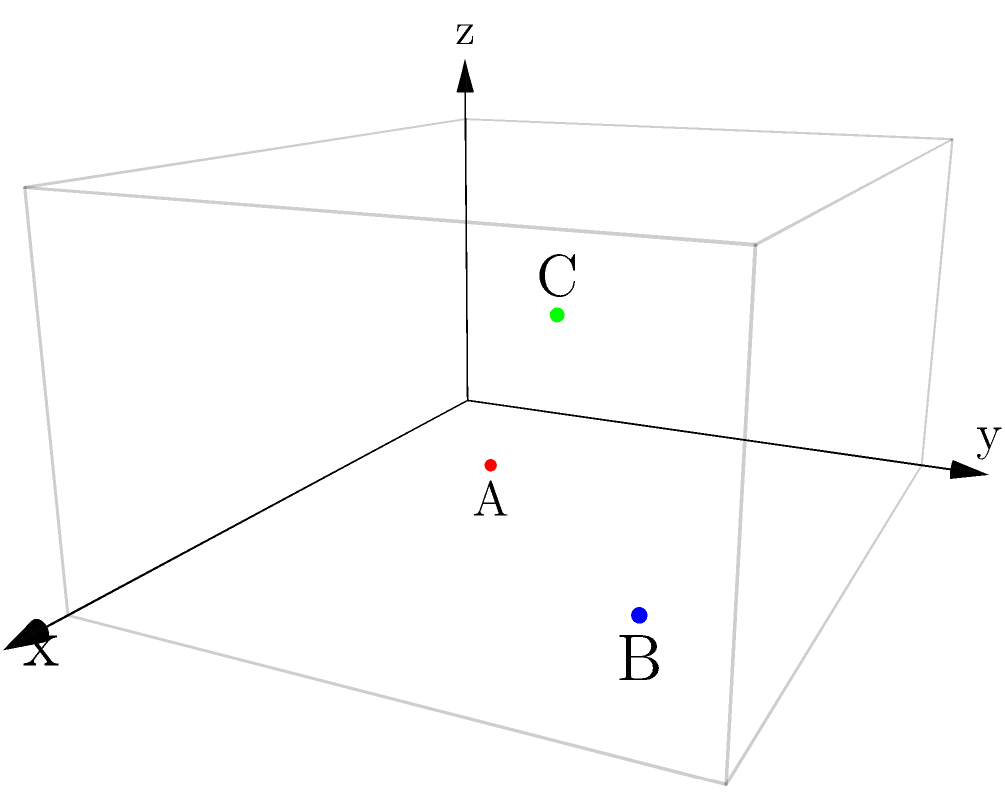In planning a new exhibition space, you're using a 3D coordinate system where each unit represents 1 meter. Three sculptures A, B, and C are placed at coordinates (3,2,0), (7,6,0), and (5,4,3) respectively. What is the shortest distance between sculptures A and C, rounded to the nearest tenth of a meter? To find the shortest distance between two points in 3D space, we can use the 3D distance formula:

$$d = \sqrt{(x_2-x_1)^2 + (y_2-y_1)^2 + (z_2-z_1)^2}$$

Where $(x_1,y_1,z_1)$ are the coordinates of the first point and $(x_2,y_2,z_2)$ are the coordinates of the second point.

Step 1: Identify the coordinates
- Sculpture A: $(3,2,0)$
- Sculpture C: $(5,4,3)$

Step 2: Apply the 3D distance formula
$$d = \sqrt{(5-3)^2 + (4-2)^2 + (3-0)^2}$$

Step 3: Simplify
$$d = \sqrt{2^2 + 2^2 + 3^2}$$
$$d = \sqrt{4 + 4 + 9}$$
$$d = \sqrt{17}$$

Step 4: Calculate and round to the nearest tenth
$$d \approx 4.1229...$$
Rounded to the nearest tenth: 4.1 meters
Answer: 4.1 meters 